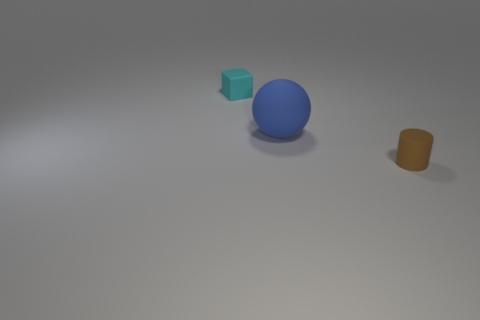Add 3 tiny brown metal blocks. How many objects exist? 6 Subtract 1 brown cylinders. How many objects are left? 2 Subtract all balls. How many objects are left? 2 Subtract 1 cubes. How many cubes are left? 0 Subtract all yellow cubes. Subtract all green balls. How many cubes are left? 1 Subtract all brown blocks. How many yellow balls are left? 0 Subtract all tiny cyan rubber objects. Subtract all large cyan metal objects. How many objects are left? 2 Add 3 brown matte cylinders. How many brown matte cylinders are left? 4 Add 2 cubes. How many cubes exist? 3 